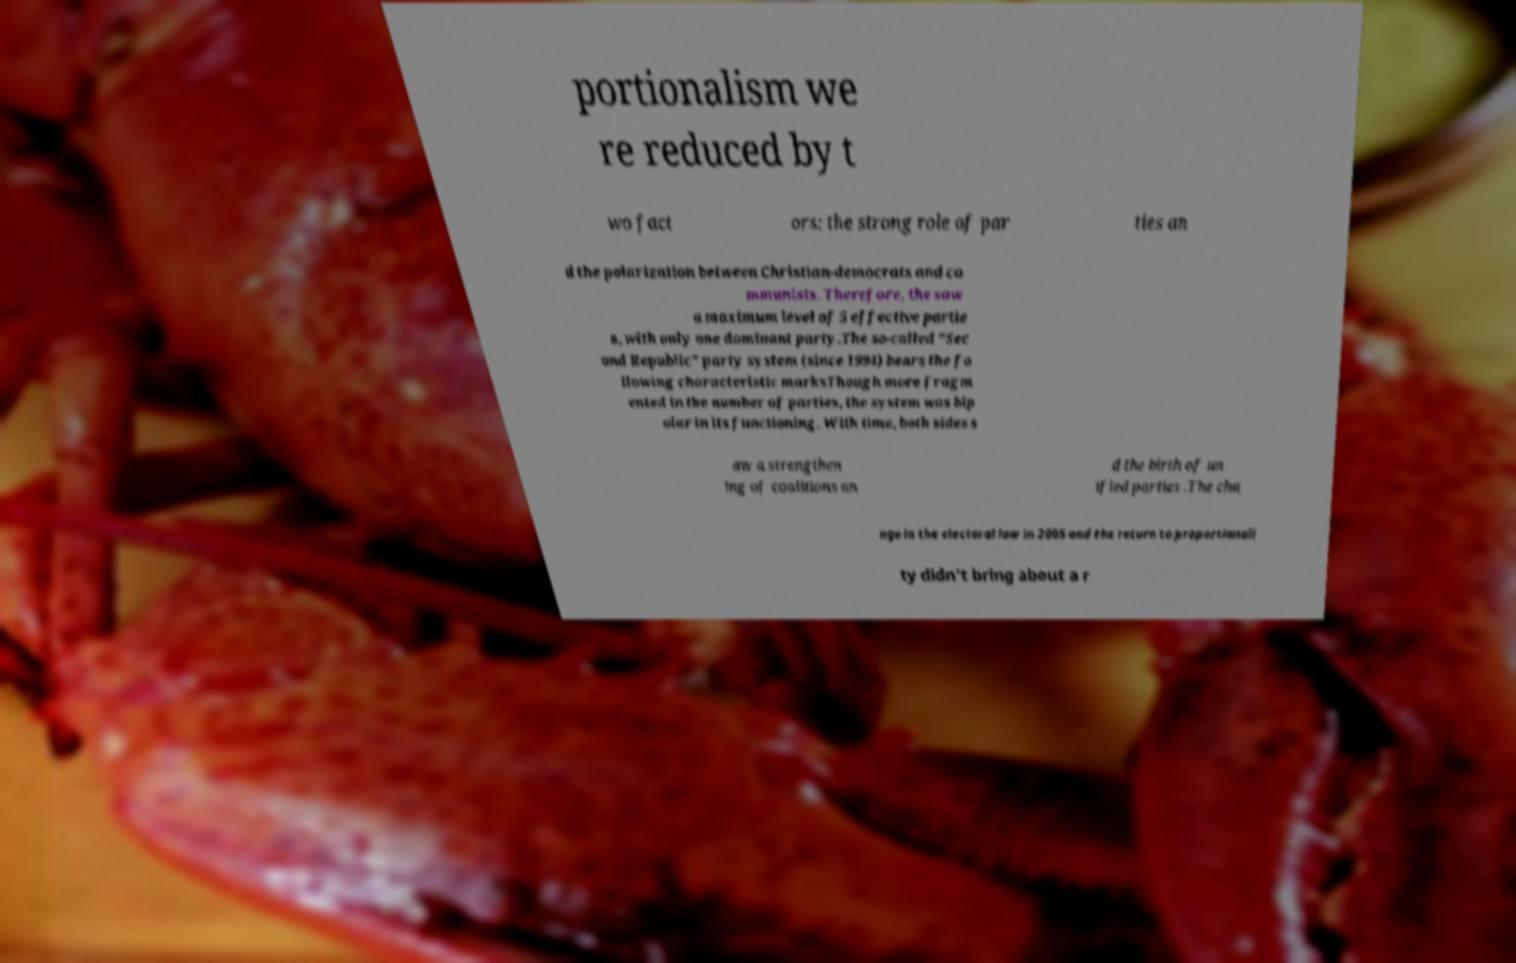What messages or text are displayed in this image? I need them in a readable, typed format. portionalism we re reduced by t wo fact ors: the strong role of par ties an d the polarization between Christian-democrats and co mmunists. Therefore, the saw a maximum level of 5 effective partie s, with only one dominant party.The so-called "Sec ond Republic" party system (since 1994) bears the fo llowing characteristic marksThough more fragm ented in the number of parties, the system was bip olar in its functioning. With time, both sides s aw a strengthen ing of coalitions an d the birth of un ified parties .The cha nge in the electoral law in 2005 and the return to proportionali ty didn't bring about a r 